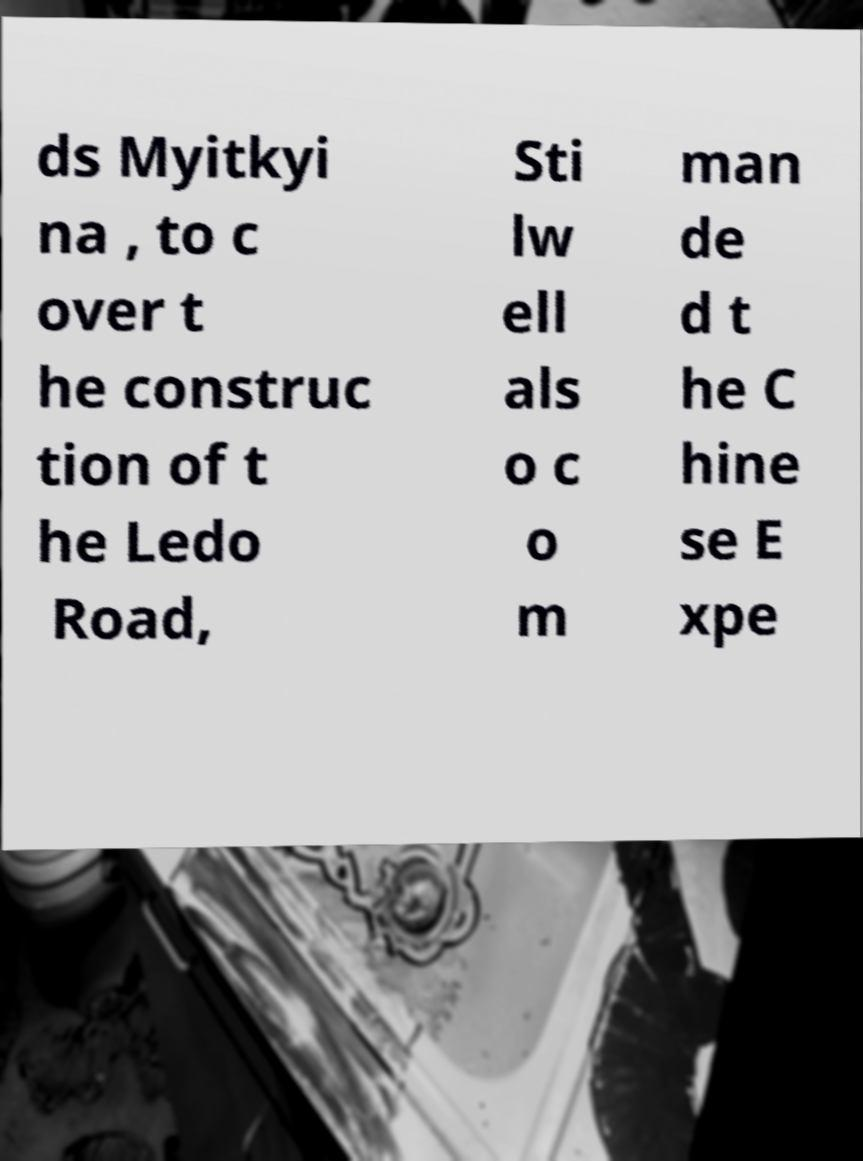Could you assist in decoding the text presented in this image and type it out clearly? ds Myitkyi na , to c over t he construc tion of t he Ledo Road, Sti lw ell als o c o m man de d t he C hine se E xpe 